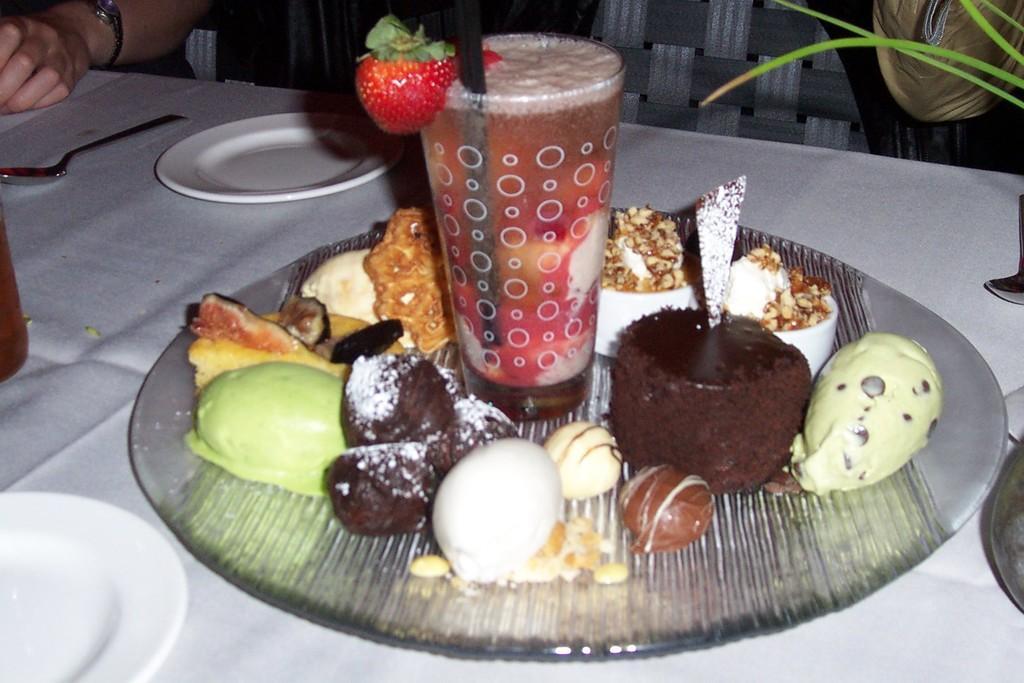Please provide a concise description of this image. In this image we can see a glass of drink and a few other food items on a plate, the plate is on top of a table and there are two other plates and a spoon on the table, in front of the table there is a chair and there is a person's hand on the table. 